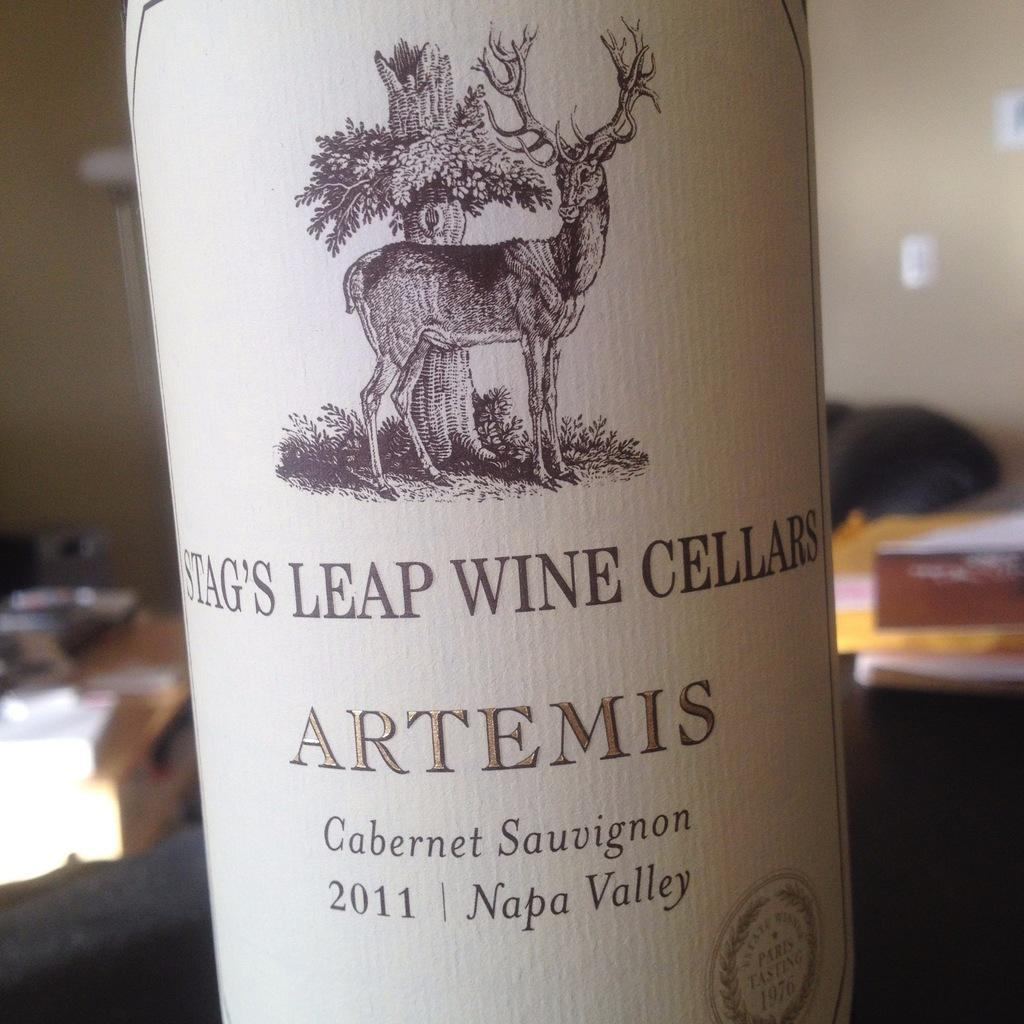What object is present in the image? There is a bottle in the image. What is on the bottle? The bottle has a sticker on it. What information is on the sticker? The sticker contains text, numbers, and an image. Can you describe the background of the image? The background of the image is blurred. What type of education does the word on the sticker represent? There is no word present on the sticker, as it contains text, numbers, and an image. 